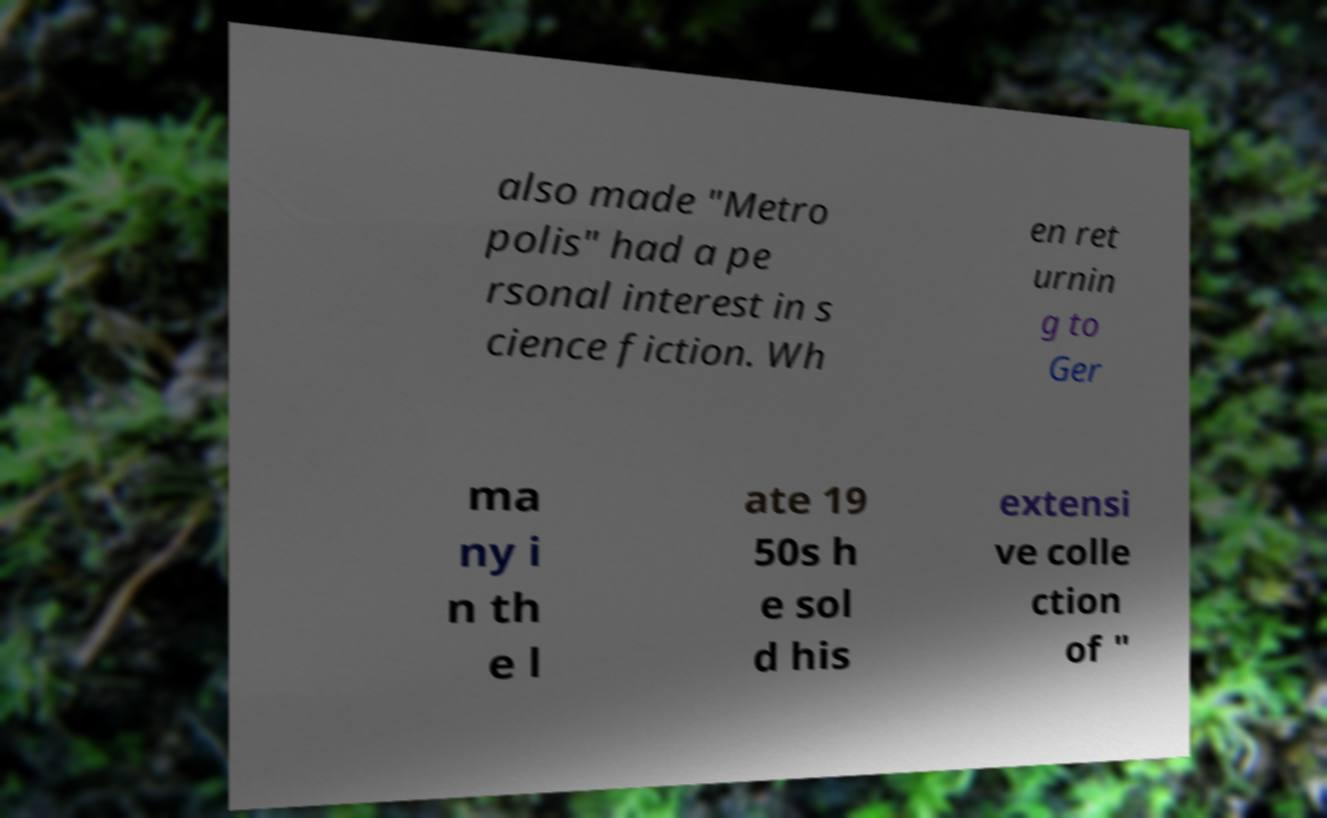I need the written content from this picture converted into text. Can you do that? also made "Metro polis" had a pe rsonal interest in s cience fiction. Wh en ret urnin g to Ger ma ny i n th e l ate 19 50s h e sol d his extensi ve colle ction of " 